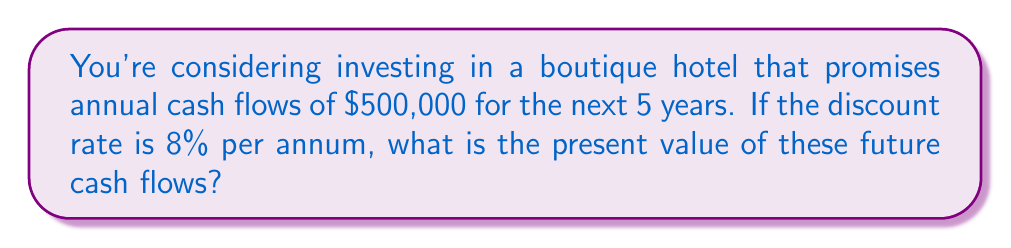Teach me how to tackle this problem. To solve this problem, we need to use the present value formula for a series of equal cash flows (an annuity). The formula is:

$$ PV = C \cdot \frac{1 - (1+r)^{-n}}{r} $$

Where:
$PV$ = Present Value
$C$ = Annual Cash Flow
$r$ = Discount Rate
$n$ = Number of Years

Let's plug in our values:

$C = \$500,000$
$r = 8\% = 0.08$
$n = 5$ years

$$ PV = 500,000 \cdot \frac{1 - (1+0.08)^{-5}}{0.08} $$

Now, let's calculate step by step:

1) First, calculate $(1+0.08)^{-5}$:
   $(1.08)^{-5} = 0.6805896$

2) Subtract this from 1:
   $1 - 0.6805896 = 0.3194104$

3) Divide by 0.08:
   $0.3194104 / 0.08 = 3.992630$

4) Multiply by 500,000:
   $500,000 * 3.992630 = 1,996,315$

Therefore, the present value of the future cash flows is $1,996,315.
Answer: $1,996,315 